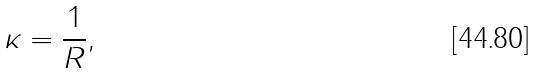<formula> <loc_0><loc_0><loc_500><loc_500>\kappa = { \frac { 1 } { R } } ,</formula> 